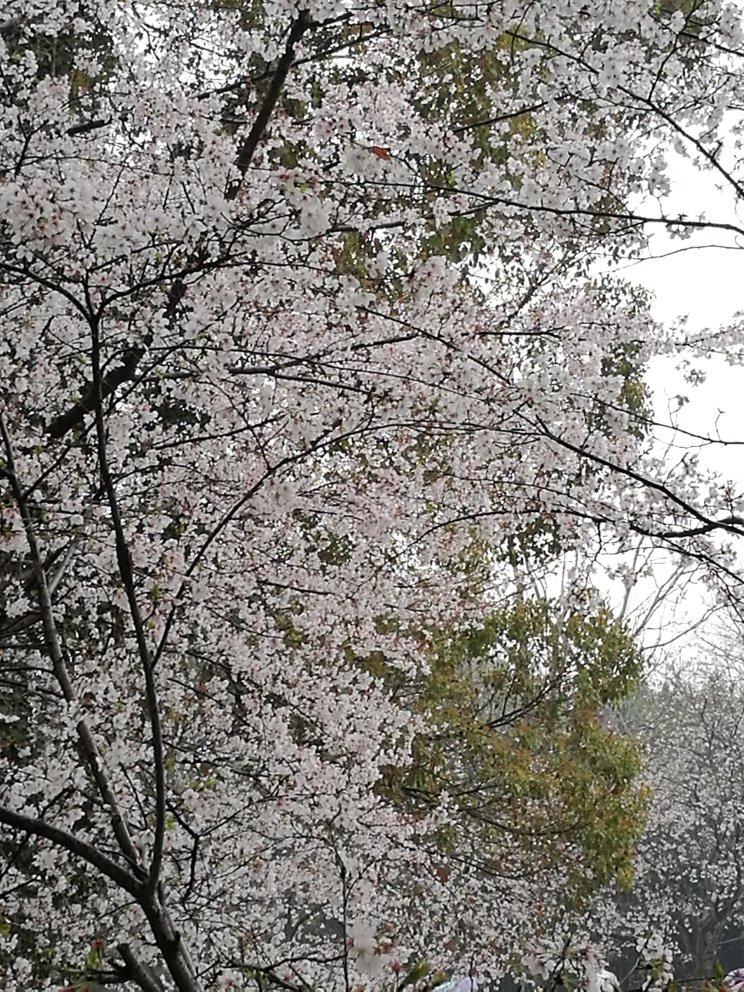How might the season in which this photo was taken influence the viewer's emotional response? The blossoming of the trees, likely in spring, often evokes feelings of renewal and optimism. The lush blooms and the contrast of the delicate flowers against the branches can offer a sense of tranquility and a reminder of the beauty and cyclicality of nature. 